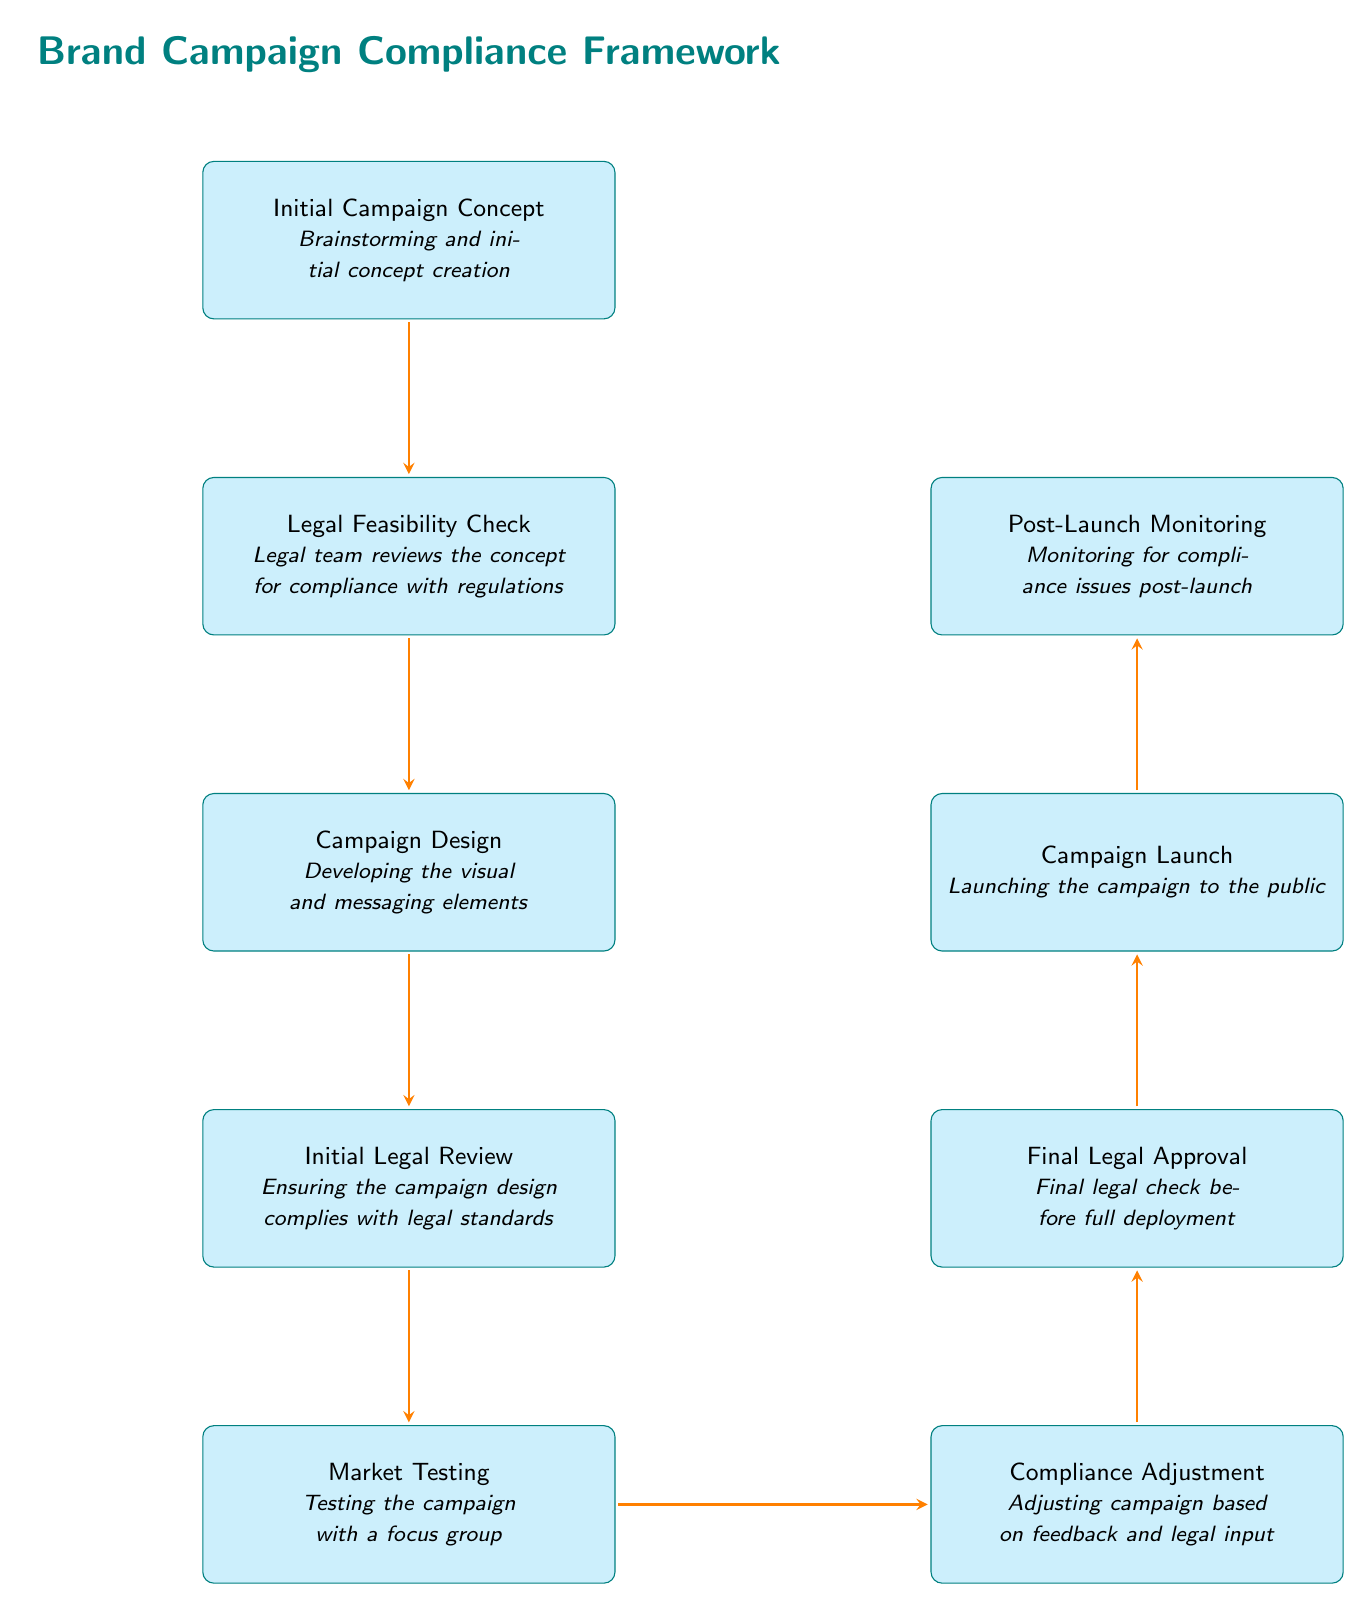What is the first step in the compliance framework? The first step in the compliance framework is the "Initial Campaign Concept," where brainstorming and initial concept creation takes place.
Answer: Initial Campaign Concept How many nodes are present in the diagram? The diagram features a total of nine nodes, which represent different stages in the compliance framework.
Answer: 9 What occurs after the Market Testing phase? After the Market Testing phase, the "Compliance Adjustment" phase takes place, where adjustments are made based on feedback and legal input.
Answer: Compliance Adjustment Which step requires final legal checks? The step that requires final legal checks is the "Final Legal Approval," which is essential before the campaign can be fully deployed.
Answer: Final Legal Approval What is the purpose of the Legal Feasibility Check? The purpose of the Legal Feasibility Check is for the legal team to review the concept for compliance with regulations.
Answer: Legal team reviews the concept for compliance What node comes immediately before the Campaign Launch? The node that comes immediately before the Campaign Launch is the "Final Legal Approval," indicating that the campaign must pass this check before launching.
Answer: Final Legal Approval What happens during the Post-Launch Monitoring phase? During the Post-Launch Monitoring phase, the campaign is monitored for compliance issues that may arise after the launch.
Answer: Monitoring for compliance issues post-launch Which two nodes are connected by the Compliance Adjustment step? The Compliance Adjustment step connects the "Market Testing" node to the "Final Legal Approval" node, indicating the iterative nature of compliance adjustments based on feedback.
Answer: Market Testing and Final Legal Approval In which phase do the marketing materials take shape? The phase where the marketing materials take shape is the "Campaign Design," where visual and messaging elements are developed.
Answer: Campaign Design 